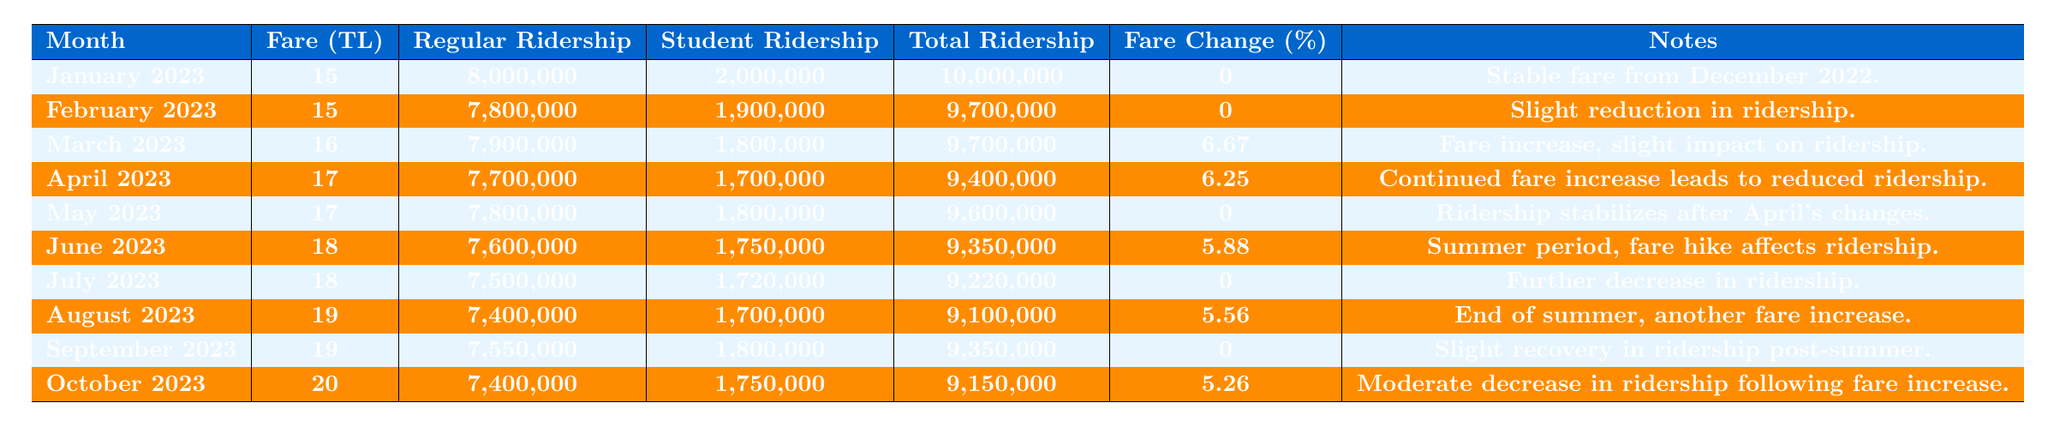What was the fare for public transportation in March 2023? The fare for public transportation in March 2023 is stated in the table as 16 TL.
Answer: 16 TL What was the total ridership in May 2023? According to the table, the total ridership for May 2023 is 9,600,000.
Answer: 9,600,000 What was the percentage change in fare from January to February 2023? The fare remained the same at 15 TL in both January and February 2023, so the percentage change is 0%.
Answer: 0% Which month had the highest total ridership? The highest total ridership occurred in January 2023, with 10,000,000 passengers, as shown in the data.
Answer: January 2023 How did the ridership of students change from February to March 2023? In February 2023, student ridership was 1,900,000, and in March 2023, it decreased to 1,800,000. Thus, it decreased by 100,000.
Answer: Decreased by 100,000 What was the total average ridership over the listed months? The total ridership values can be summed up for all months (10,000,000 + 9,700,000 + 9,700,000 + 9,400,000 + 9,600,000 + 9,350,000 + 9,220,000 + 9,100,000 + 9,350,000 + 9,150,000 = 96,400,000), and dividing by 10 (the number of months) gives an average of 9,640,000.
Answer: 9,640,000 Was there a fare increase in July 2023 compared to June 2023? No, the fare remained at 18 TL in both June and July 2023, indicating no increase.
Answer: No How did the total ridership change from April to August 2023? Total ridership in April 2023 was 9,400,000 and in August 2023 it decreased to 9,100,000. The change is a decrease of 300,000.
Answer: Decreased by 300,000 What was the fare change percentage from June to July 2023? Both months had the same fare of 18 TL, which means the fare change percentage is 0%.
Answer: 0% In which month was the largest fare increase recorded? The largest fare increase was from March to April 2023, moving from 16 TL to 17 TL, a 6.25% increase.
Answer: April 2023 What was the trend in regular ridership from January to October 2023? Regular ridership started at 8,000,000 in January and decreased over the following months with minor fluctuations, landing at 7,400,000 in October, suggesting a downward trend overall.
Answer: Downward trend 